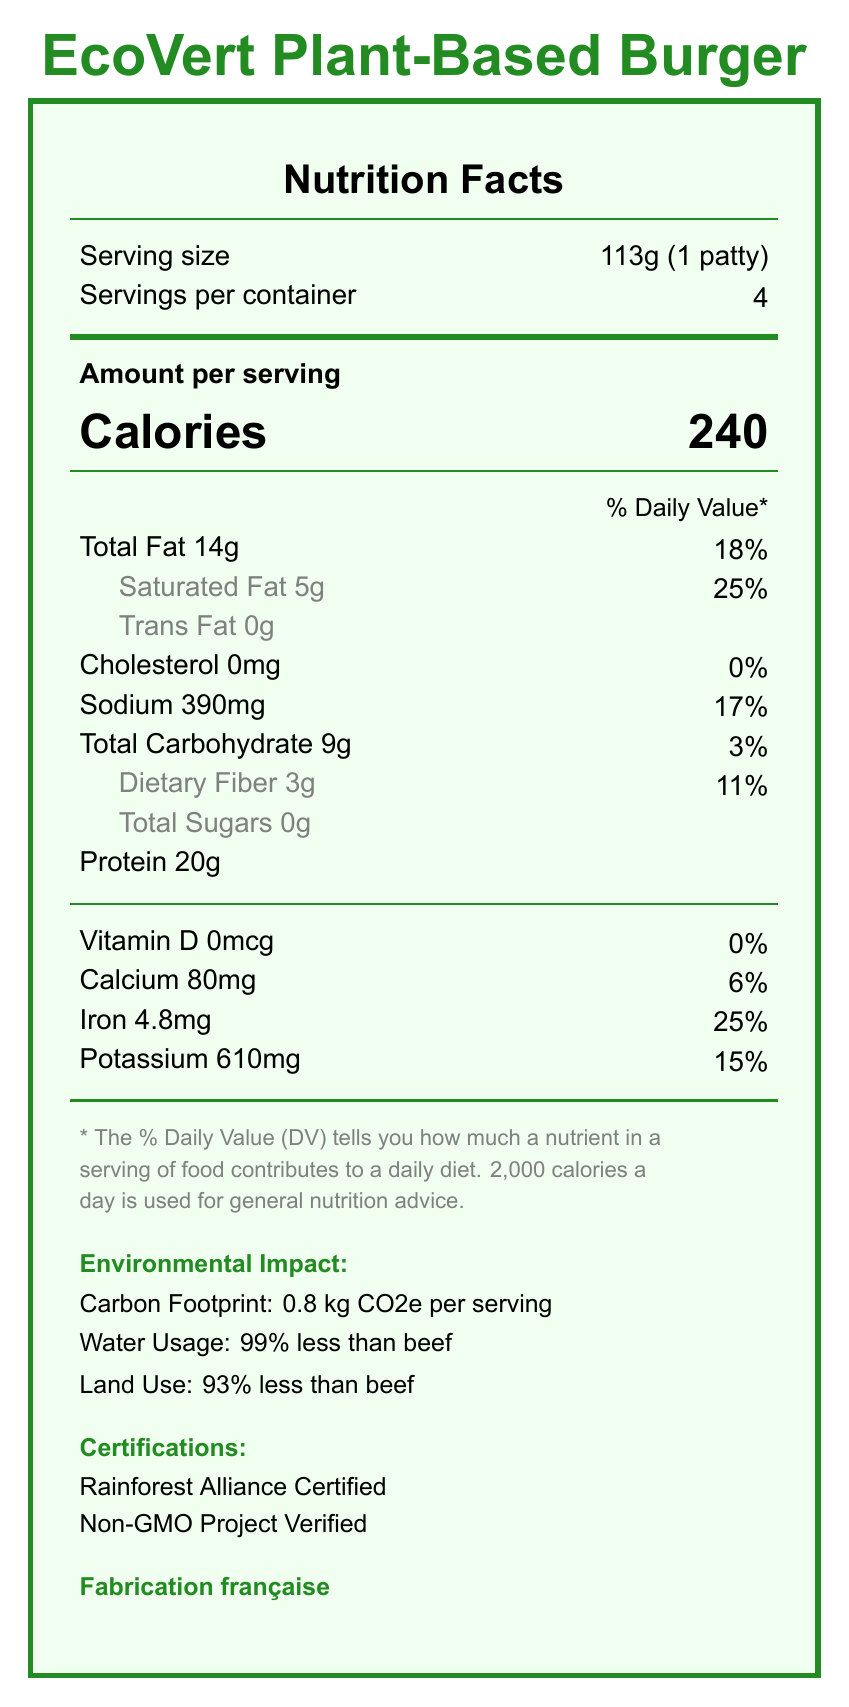what is the serving size of EcoVert Plant-Based Burger? The serving size is explicitly mentioned as "113g (1 patty)" in the document.
Answer: 113g (1 patty) how many servings are there per container? The document states "Servings per container: 4."
Answer: 4 what is the total amount of protein per serving? According to the document, each serving contains 20g of protein.
Answer: 20g what certifications has the EcoVert Plant-Based Burger received? The certifications listed in the document are "Rainforest Alliance Certified" and "Non-GMO Project Verified."
Answer: Rainforest Alliance Certified, Non-GMO Project Verified what is the carbon footprint per serving? The document specifies "Carbon Footprint: 0.8 kg CO2e per serving" under Environmental Impact.
Answer: 0.8 kg CO2e what is the daily value percentage of sodium per serving? The document mentions that each serving contains 390mg of sodium, which is 17% of the daily value.
Answer: 17% what percentage of land does the EcoVert Plant-Based Burger use compared to beef? The Environmental Impact section of the document says it uses "93% less land than beef."
Answer: 93% less which mineral present in the burger contributes the highest daily value? A. Calcium B. Iron C. Potassium D. Vitamin D Iron has a daily value percentage of 25%, which is the highest among the listed minerals.
Answer: B. Iron how much dietary fiber does one serving contain? A. 0g B. 1g C. 3g D. 5g The document lists the amount of dietary fiber per serving as 3g.
Answer: C. 3g The EcoVert Plant-Based Burger is produced in which country? The document states "Fabrication française," which means it's made in France.
Answer: France true or false: The EcoVert Plant-Based Burger contains gluten. The ingredients listed do not include gluten, so the statement is false.
Answer: False what is the main idea of the document? The document covers various aspects like nutrition facts, environmental benefits, certifications, and ethical sourcing of the EcoVert Plant-Based Burger.
Answer: The document provides nutritional information, environmental impact, certifications, and details about the EcoVert Plant-Based Burger. how much energy reduction is achieved compared to beef according to the document? The comparison to beef section mentions "energy use: 46% lower."
Answer: 46% lower are there any non-GMO ingredients in the EcoVert Plant-Based Burger? The burger has been certified as "Non-GMO Project Verified."
Answer: Yes what is the exact amount of cholesterol per serving? The document specifies that the cholesterol content per serving is 0mg.
Answer: 0mg which ingredient is used for coloring in the burger? Among the listed ingredients, "beet juice extract (for color)" is used for coloring.
Answer: Beet juice extract how much water savings is achieved compared to beef? The document highlights that the burger uses "99% less water than beef."
Answer: 99% less what is the level of Vitamin D in the burger? The document shows that the Vitamin D content is 0mcg.
Answer: 0mcg how much saturated fat is in one serving? The document states that one serving contains 5g of saturated fat.
Answer: 5g how much of the packaging is recyclable? The document mentions that the packaging is "100% recycled and recyclable cardboard."
Answer: 100% who are the local farmers supported by EcoVert? The document states that EcoVert supports local French farmers, but it does not specify who they are.
Answer: Not enough information 